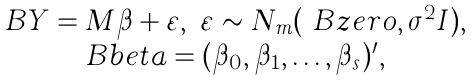<formula> <loc_0><loc_0><loc_500><loc_500>\begin{array} { c } \ B Y = M \beta + \varepsilon , \ \varepsilon \sim N _ { m } ( \ B z e r o , \sigma ^ { 2 } I ) , \\ \ B b e t a = ( \beta _ { 0 } , \beta _ { 1 } , \dots , \beta _ { s } ) ^ { \prime } , \end{array}</formula> 